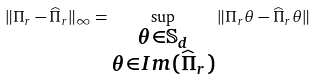Convert formula to latex. <formula><loc_0><loc_0><loc_500><loc_500>\| \Pi _ { r } - \widehat { \Pi } _ { r } \| _ { \infty } = \sup _ { \substack { \theta \in \mathbb { S } _ { d } \\ \theta \in I m ( \widehat { \Pi } _ { r } ) } } \| \Pi _ { r } \theta - \widehat { \Pi } _ { r } \theta \|</formula> 